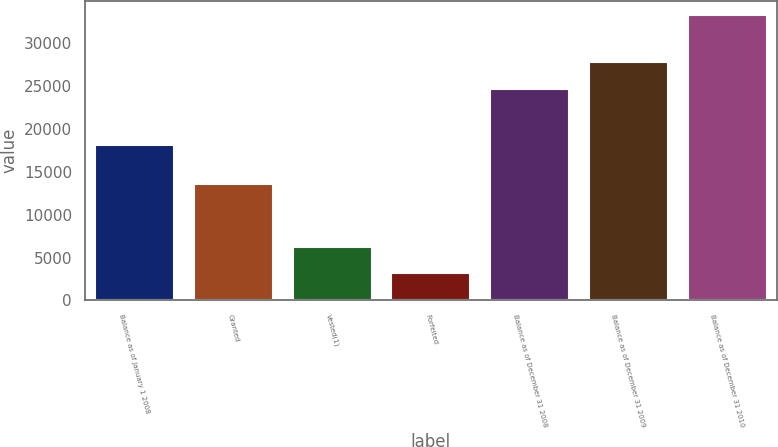Convert chart. <chart><loc_0><loc_0><loc_500><loc_500><bar_chart><fcel>Balance as of January 1 2008<fcel>Granted<fcel>Vested(1)<fcel>Forfeited<fcel>Balance as of December 31 2008<fcel>Balance as of December 31 2009<fcel>Balance as of December 31 2010<nl><fcel>18136<fcel>13557<fcel>6193.1<fcel>3183<fcel>24654<fcel>27890<fcel>33284<nl></chart> 